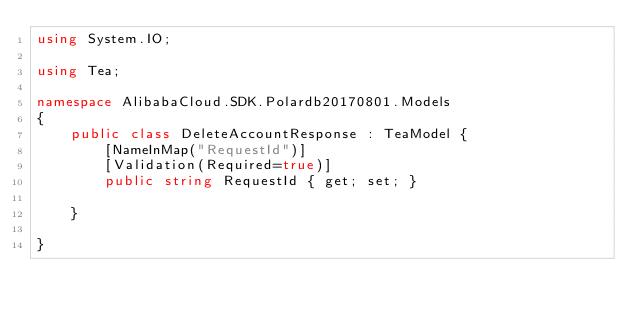<code> <loc_0><loc_0><loc_500><loc_500><_C#_>using System.IO;

using Tea;

namespace AlibabaCloud.SDK.Polardb20170801.Models
{
    public class DeleteAccountResponse : TeaModel {
        [NameInMap("RequestId")]
        [Validation(Required=true)]
        public string RequestId { get; set; }

    }

}
</code> 